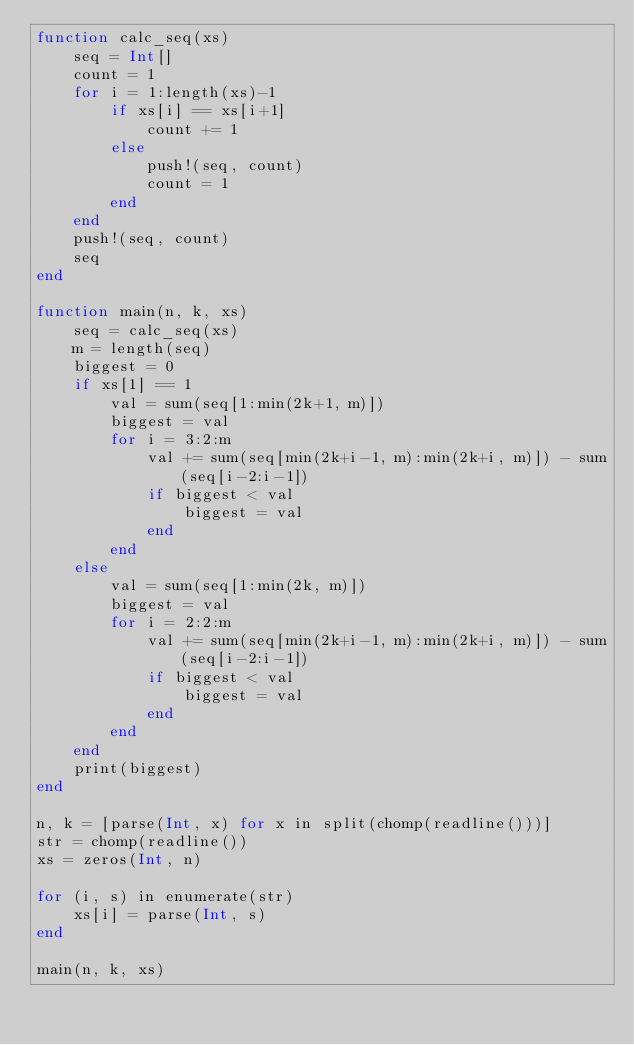Convert code to text. <code><loc_0><loc_0><loc_500><loc_500><_Julia_>function calc_seq(xs)
    seq = Int[]
    count = 1
    for i = 1:length(xs)-1
        if xs[i] == xs[i+1]
            count += 1
        else
            push!(seq, count)
            count = 1
        end
    end
    push!(seq, count)
    seq
end

function main(n, k, xs)
    seq = calc_seq(xs)
    m = length(seq)
    biggest = 0
    if xs[1] == 1
        val = sum(seq[1:min(2k+1, m)])
        biggest = val
        for i = 3:2:m
            val += sum(seq[min(2k+i-1, m):min(2k+i, m)]) - sum(seq[i-2:i-1])
            if biggest < val
                biggest = val
            end
        end
    else
        val = sum(seq[1:min(2k, m)])
        biggest = val
        for i = 2:2:m
            val += sum(seq[min(2k+i-1, m):min(2k+i, m)]) - sum(seq[i-2:i-1])
            if biggest < val
                biggest = val
            end
        end
    end
    print(biggest)
end

n, k = [parse(Int, x) for x in split(chomp(readline()))]
str = chomp(readline())
xs = zeros(Int, n)

for (i, s) in enumerate(str)
    xs[i] = parse(Int, s)
end

main(n, k, xs)</code> 